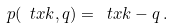<formula> <loc_0><loc_0><loc_500><loc_500>p ( \ t x k , q ) = \ t x k - q \, .</formula> 